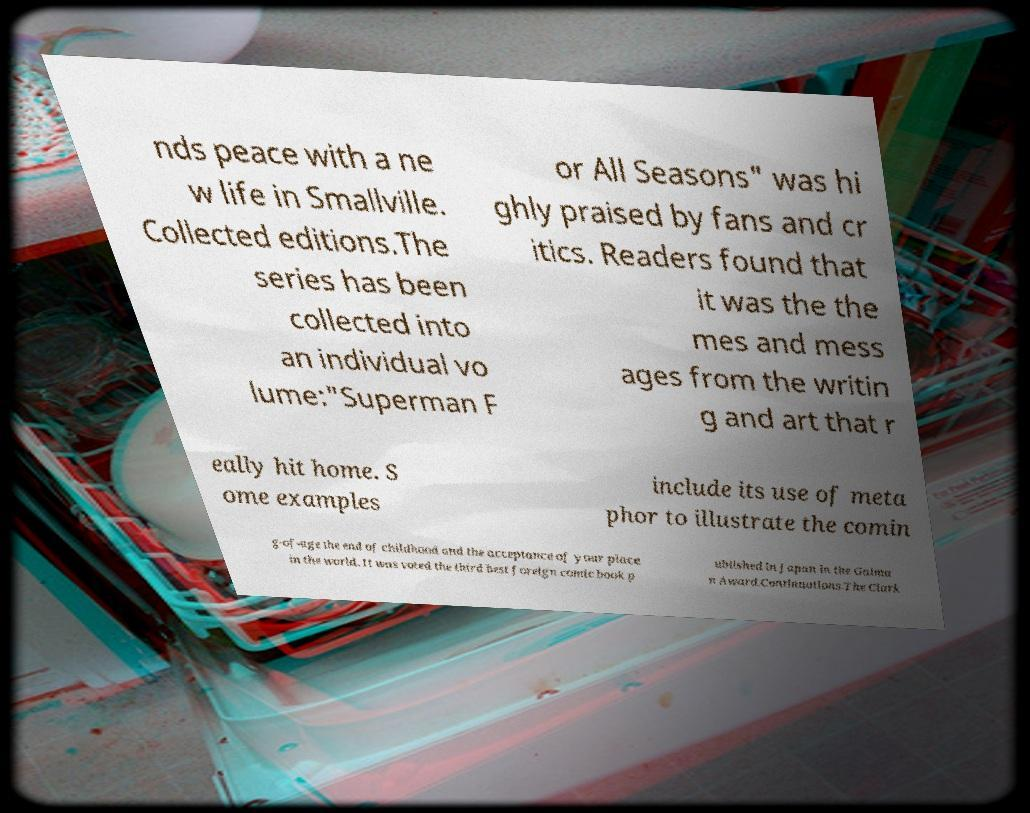What messages or text are displayed in this image? I need them in a readable, typed format. nds peace with a ne w life in Smallville. Collected editions.The series has been collected into an individual vo lume:"Superman F or All Seasons" was hi ghly praised by fans and cr itics. Readers found that it was the the mes and mess ages from the writin g and art that r eally hit home. S ome examples include its use of meta phor to illustrate the comin g-of-age the end of childhood and the acceptance of your place in the world. It was voted the third best foreign comic book p ublished in Japan in the Gaima n Award.Continuations.The Clark 